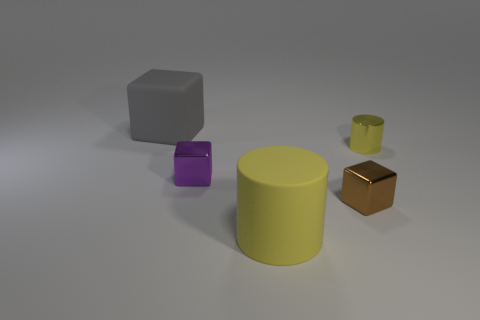Are there more cylinders behind the purple cube than green shiny blocks?
Give a very brief answer. Yes. What shape is the tiny purple object in front of the matte object on the left side of the yellow object in front of the purple shiny thing?
Your answer should be compact. Cube. There is a large object that is to the right of the big gray matte thing; is its shape the same as the small brown object that is on the right side of the large yellow thing?
Make the answer very short. No. What number of cylinders are matte things or tiny yellow metallic things?
Your answer should be compact. 2. Do the small purple object and the small yellow cylinder have the same material?
Your answer should be compact. Yes. How many other things are the same color as the big rubber block?
Keep it short and to the point. 0. What shape is the rubber object that is right of the gray matte object?
Ensure brevity in your answer.  Cylinder. How many things are either shiny balls or metal objects?
Your answer should be compact. 3. There is a gray rubber object; is its size the same as the rubber object in front of the tiny shiny cylinder?
Offer a very short reply. Yes. What number of other objects are there of the same material as the purple cube?
Give a very brief answer. 2. 